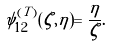<formula> <loc_0><loc_0><loc_500><loc_500>\psi _ { 1 2 } ^ { ( T ) } ( \zeta , \eta ) = \frac { \eta } { \zeta } .</formula> 